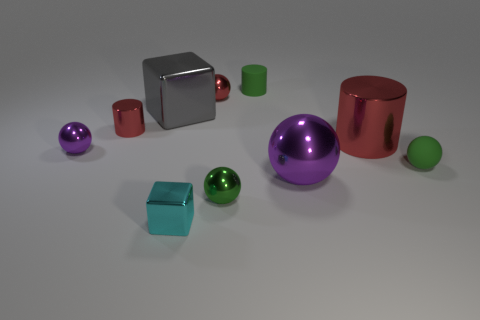Subtract all red spheres. How many spheres are left? 4 Subtract all large purple balls. How many balls are left? 4 Subtract 1 balls. How many balls are left? 4 Subtract all yellow balls. Subtract all cyan cubes. How many balls are left? 5 Subtract all cubes. How many objects are left? 8 Add 4 red metallic cylinders. How many red metallic cylinders are left? 6 Add 4 cyan objects. How many cyan objects exist? 5 Subtract 0 green blocks. How many objects are left? 10 Subtract all tiny purple metallic objects. Subtract all green matte objects. How many objects are left? 7 